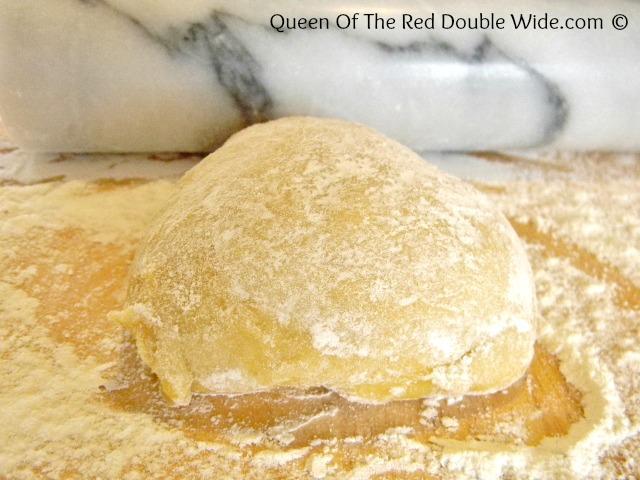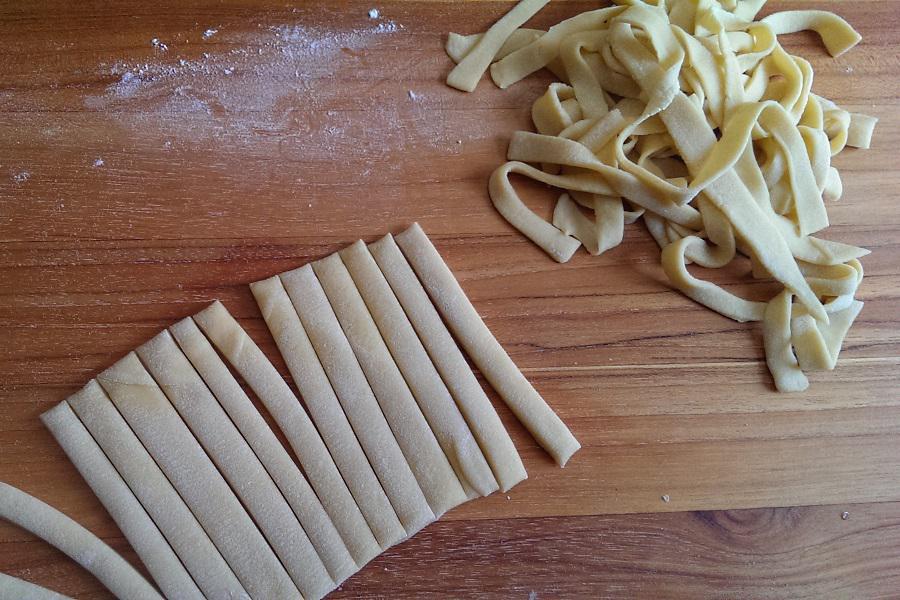The first image is the image on the left, the second image is the image on the right. Evaluate the accuracy of this statement regarding the images: "One photo shows clearly visible eggs being used as an ingredient and the other image shows completed homemade noodles.". Is it true? Answer yes or no. No. 